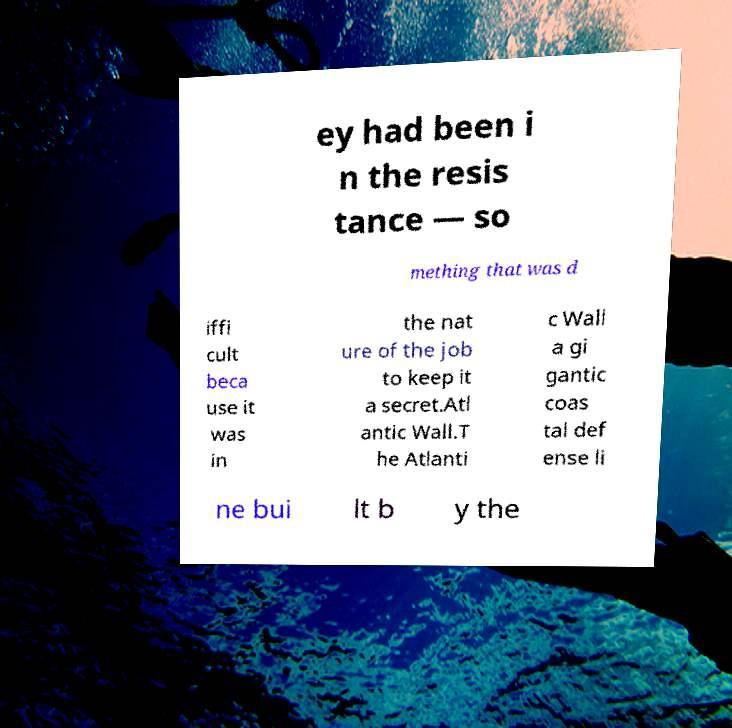Can you read and provide the text displayed in the image?This photo seems to have some interesting text. Can you extract and type it out for me? ey had been i n the resis tance — so mething that was d iffi cult beca use it was in the nat ure of the job to keep it a secret.Atl antic Wall.T he Atlanti c Wall a gi gantic coas tal def ense li ne bui lt b y the 